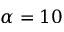<formula> <loc_0><loc_0><loc_500><loc_500>\alpha = 1 0</formula> 